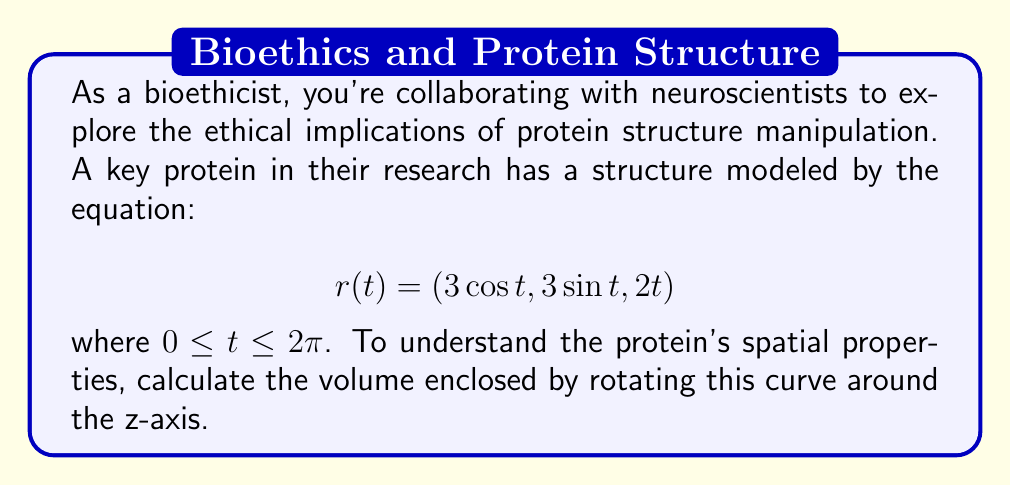Show me your answer to this math problem. To solve this problem, we'll use the method of cylindrical shells for volume calculation. The steps are as follows:

1) The volume of a cylindrical shell is given by $2\pi r h \Delta r$, where $r$ is the radius from the axis of rotation, $h$ is the height of the shell, and $\Delta r$ is the thickness of the shell.

2) In our case, the radius from the z-axis at any point is:
   $$r(t) = \sqrt{x^2 + y^2} = \sqrt{(3\cos t)^2 + (3\sin t)^2} = 3$$

3) The height of each shell is the z-component: $h = 2t$

4) To get the volume, we integrate over the entire curve:

   $$V = \int_0^{2\pi} 2\pi r h \,dt = \int_0^{2\pi} 2\pi (3)(2t) \,dt$$

5) Simplifying:
   $$V = 12\pi \int_0^{2\pi} t \,dt$$

6) Integrating:
   $$V = 12\pi \left[\frac{1}{2}t^2\right]_0^{2\pi} = 12\pi \left[\frac{1}{2}(2\pi)^2 - 0\right] = 12\pi^3$$

This result gives us the volume in cubic units (assuming the original equation was in some consistent unit of length).
Answer: $12\pi^3$ cubic units 